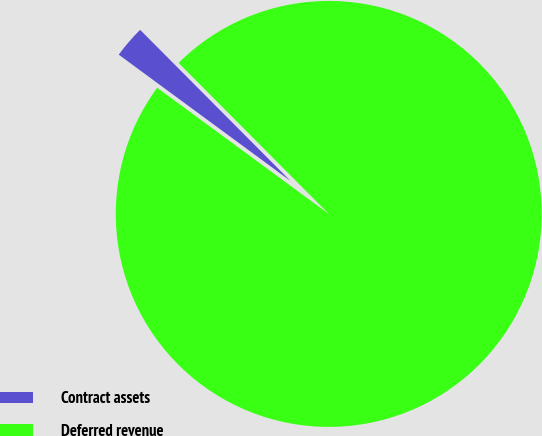<chart> <loc_0><loc_0><loc_500><loc_500><pie_chart><fcel>Contract assets<fcel>Deferred revenue<nl><fcel>2.45%<fcel>97.55%<nl></chart> 